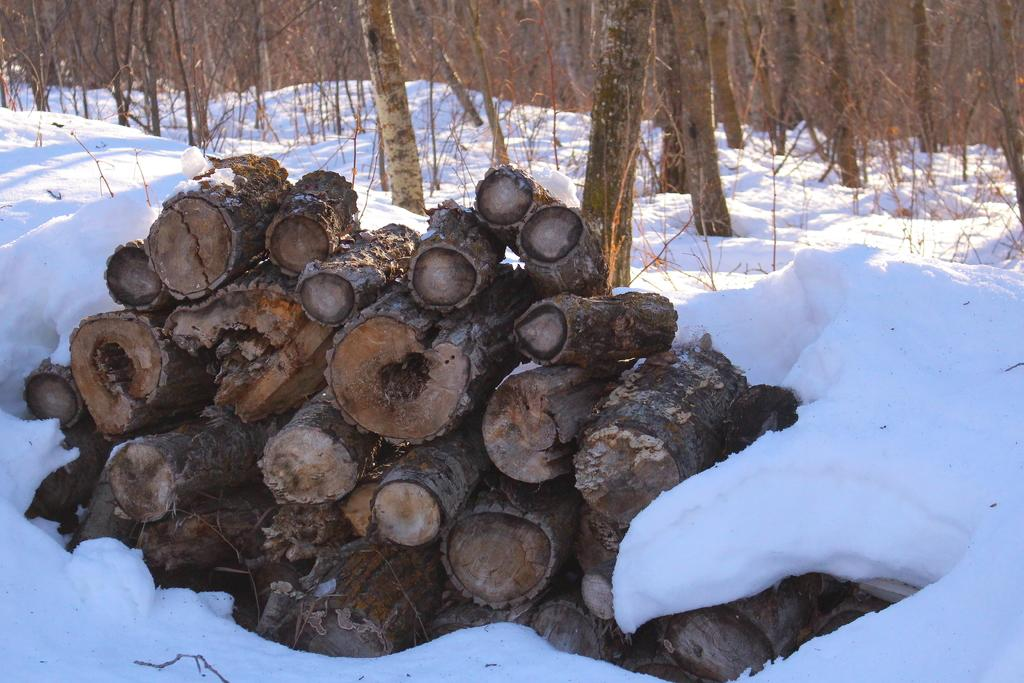What is the condition of the ground in the image? The ground is covered in snow. What object can be seen on the snow-covered ground? There is a log of wood on the snow-covered ground. What can be seen in the background of the image? There are trees visible in the background of the image. What type of ink can be seen dripping from the wall in the image? There is no wall or ink present in the image; it features a snow-covered ground with a log of wood and trees in the background. 